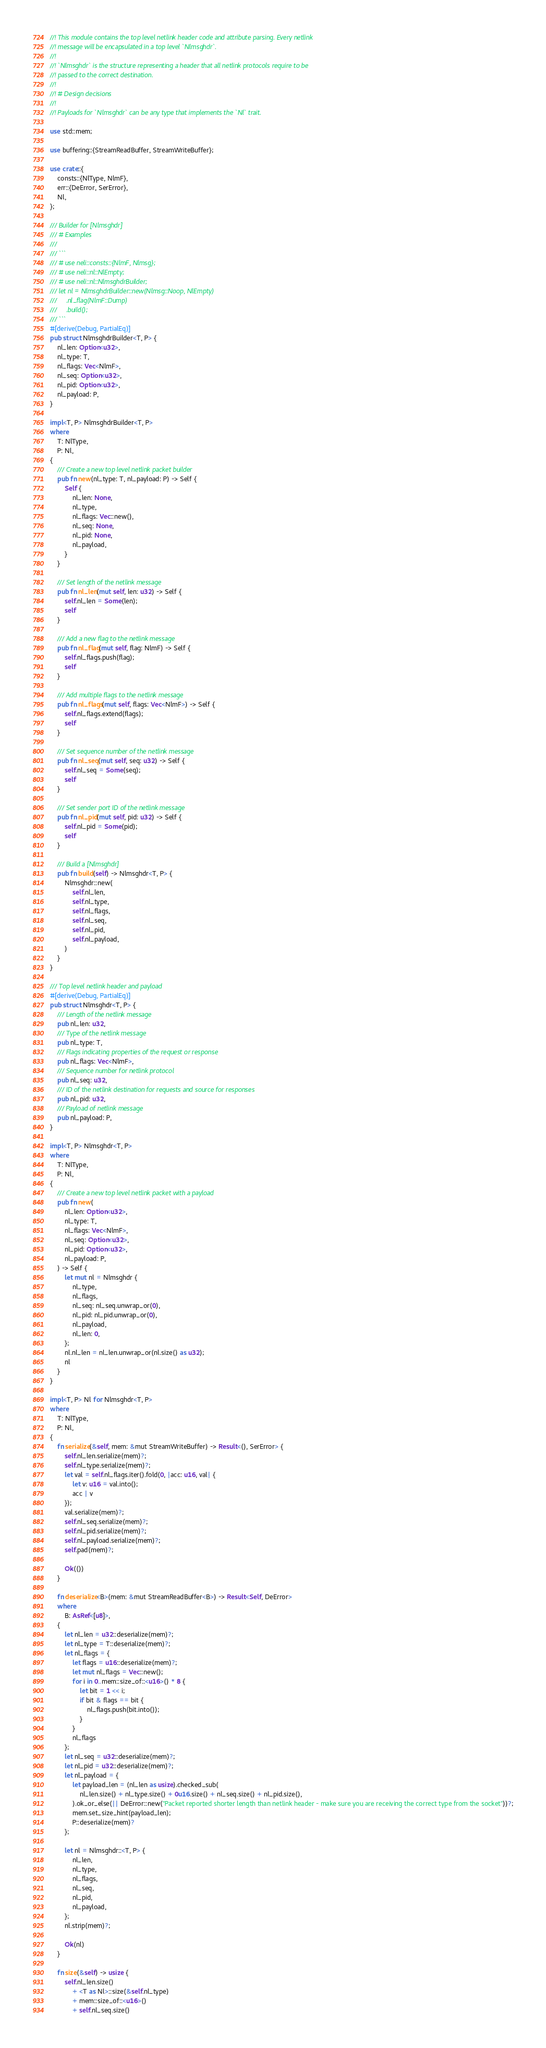Convert code to text. <code><loc_0><loc_0><loc_500><loc_500><_Rust_>//! This module contains the top level netlink header code and attribute parsing. Every netlink
//! message will be encapsulated in a top level `Nlmsghdr`.
//!
//! `Nlmsghdr` is the structure representing a header that all netlink protocols require to be
//! passed to the correct destination.
//!
//! # Design decisions
//!
//! Payloads for `Nlmsghdr` can be any type that implements the `Nl` trait.

use std::mem;

use buffering::{StreamReadBuffer, StreamWriteBuffer};

use crate::{
    consts::{NlType, NlmF},
    err::{DeError, SerError},
    Nl,
};

/// Builder for [Nlmsghdr]
/// # Examples
///
/// ```
/// # use neli::consts::{NlmF, Nlmsg};
/// # use neli::nl::NlEmpty;
/// # use neli::nl::NlmsghdrBuilder;
/// let nl = NlmsghdrBuilder::new(Nlmsg::Noop, NlEmpty)
///     .nl_flag(NlmF::Dump)
///     .build();
/// ```
#[derive(Debug, PartialEq)]
pub struct NlmsghdrBuilder<T, P> {
    nl_len: Option<u32>,
    nl_type: T,
    nl_flags: Vec<NlmF>,
    nl_seq: Option<u32>,
    nl_pid: Option<u32>,
    nl_payload: P,
}

impl<T, P> NlmsghdrBuilder<T, P>
where
    T: NlType,
    P: Nl,
{
    /// Create a new top level netlink packet builder
    pub fn new(nl_type: T, nl_payload: P) -> Self {
        Self {
            nl_len: None,
            nl_type,
            nl_flags: Vec::new(),
            nl_seq: None,
            nl_pid: None,
            nl_payload,
        }
    }

    /// Set length of the netlink message
    pub fn nl_len(mut self, len: u32) -> Self {
        self.nl_len = Some(len);
        self
    }

    /// Add a new flag to the netlink message
    pub fn nl_flag(mut self, flag: NlmF) -> Self {
        self.nl_flags.push(flag);
        self
    }

    /// Add multiple flags to the netlink message
    pub fn nl_flags(mut self, flags: Vec<NlmF>) -> Self {
        self.nl_flags.extend(flags);
        self
    }

    /// Set sequence number of the netlink message
    pub fn nl_seq(mut self, seq: u32) -> Self {
        self.nl_seq = Some(seq);
        self
    }

    /// Set sender port ID of the netlink message
    pub fn nl_pid(mut self, pid: u32) -> Self {
        self.nl_pid = Some(pid);
        self
    }

    /// Build a [Nlmsghdr]
    pub fn build(self) -> Nlmsghdr<T, P> {
        Nlmsghdr::new(
            self.nl_len,
            self.nl_type,
            self.nl_flags,
            self.nl_seq,
            self.nl_pid,
            self.nl_payload,
        )
    }
}

/// Top level netlink header and payload
#[derive(Debug, PartialEq)]
pub struct Nlmsghdr<T, P> {
    /// Length of the netlink message
    pub nl_len: u32,
    /// Type of the netlink message
    pub nl_type: T,
    /// Flags indicating properties of the request or response
    pub nl_flags: Vec<NlmF>,
    /// Sequence number for netlink protocol
    pub nl_seq: u32,
    /// ID of the netlink destination for requests and source for responses
    pub nl_pid: u32,
    /// Payload of netlink message
    pub nl_payload: P,
}

impl<T, P> Nlmsghdr<T, P>
where
    T: NlType,
    P: Nl,
{
    /// Create a new top level netlink packet with a payload
    pub fn new(
        nl_len: Option<u32>,
        nl_type: T,
        nl_flags: Vec<NlmF>,
        nl_seq: Option<u32>,
        nl_pid: Option<u32>,
        nl_payload: P,
    ) -> Self {
        let mut nl = Nlmsghdr {
            nl_type,
            nl_flags,
            nl_seq: nl_seq.unwrap_or(0),
            nl_pid: nl_pid.unwrap_or(0),
            nl_payload,
            nl_len: 0,
        };
        nl.nl_len = nl_len.unwrap_or(nl.size() as u32);
        nl
    }
}

impl<T, P> Nl for Nlmsghdr<T, P>
where
    T: NlType,
    P: Nl,
{
    fn serialize(&self, mem: &mut StreamWriteBuffer) -> Result<(), SerError> {
        self.nl_len.serialize(mem)?;
        self.nl_type.serialize(mem)?;
        let val = self.nl_flags.iter().fold(0, |acc: u16, val| {
            let v: u16 = val.into();
            acc | v
        });
        val.serialize(mem)?;
        self.nl_seq.serialize(mem)?;
        self.nl_pid.serialize(mem)?;
        self.nl_payload.serialize(mem)?;
        self.pad(mem)?;

        Ok(())
    }

    fn deserialize<B>(mem: &mut StreamReadBuffer<B>) -> Result<Self, DeError>
    where
        B: AsRef<[u8]>,
    {
        let nl_len = u32::deserialize(mem)?;
        let nl_type = T::deserialize(mem)?;
        let nl_flags = {
            let flags = u16::deserialize(mem)?;
            let mut nl_flags = Vec::new();
            for i in 0..mem::size_of::<u16>() * 8 {
                let bit = 1 << i;
                if bit & flags == bit {
                    nl_flags.push(bit.into());
                }
            }
            nl_flags
        };
        let nl_seq = u32::deserialize(mem)?;
        let nl_pid = u32::deserialize(mem)?;
        let nl_payload = {
            let payload_len = (nl_len as usize).checked_sub(
                nl_len.size() + nl_type.size() + 0u16.size() + nl_seq.size() + nl_pid.size(),
            ).ok_or_else(|| DeError::new("Packet reported shorter length than netlink header - make sure you are receiving the correct type from the socket"))?;
            mem.set_size_hint(payload_len);
            P::deserialize(mem)?
        };

        let nl = Nlmsghdr::<T, P> {
            nl_len,
            nl_type,
            nl_flags,
            nl_seq,
            nl_pid,
            nl_payload,
        };
        nl.strip(mem)?;

        Ok(nl)
    }

    fn size(&self) -> usize {
        self.nl_len.size()
            + <T as Nl>::size(&self.nl_type)
            + mem::size_of::<u16>()
            + self.nl_seq.size()</code> 